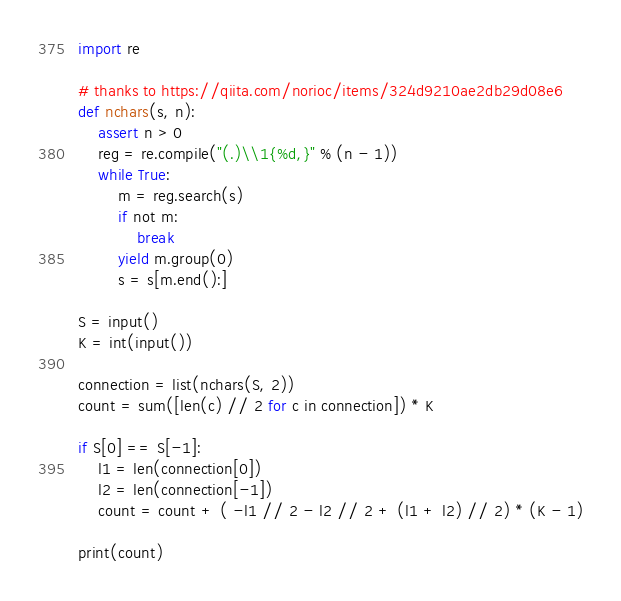<code> <loc_0><loc_0><loc_500><loc_500><_Python_>import re

# thanks to https://qiita.com/norioc/items/324d9210ae2db29d08e6
def nchars(s, n):
    assert n > 0
    reg = re.compile("(.)\\1{%d,}" % (n - 1))
    while True:
        m = reg.search(s)
        if not m:
            break
        yield m.group(0)
        s = s[m.end():]

S = input()
K = int(input())

connection = list(nchars(S, 2))
count = sum([len(c) // 2 for c in connection]) * K

if S[0] == S[-1]:
    l1 = len(connection[0])
    l2 = len(connection[-1])
    count = count + ( -l1 // 2 - l2 // 2 + (l1 + l2) // 2) * (K - 1)

print(count)</code> 